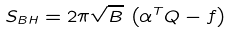Convert formula to latex. <formula><loc_0><loc_0><loc_500><loc_500>S _ { B H } = 2 \pi \sqrt { B } \, \left ( { \alpha ^ { T } Q } - f \right )</formula> 